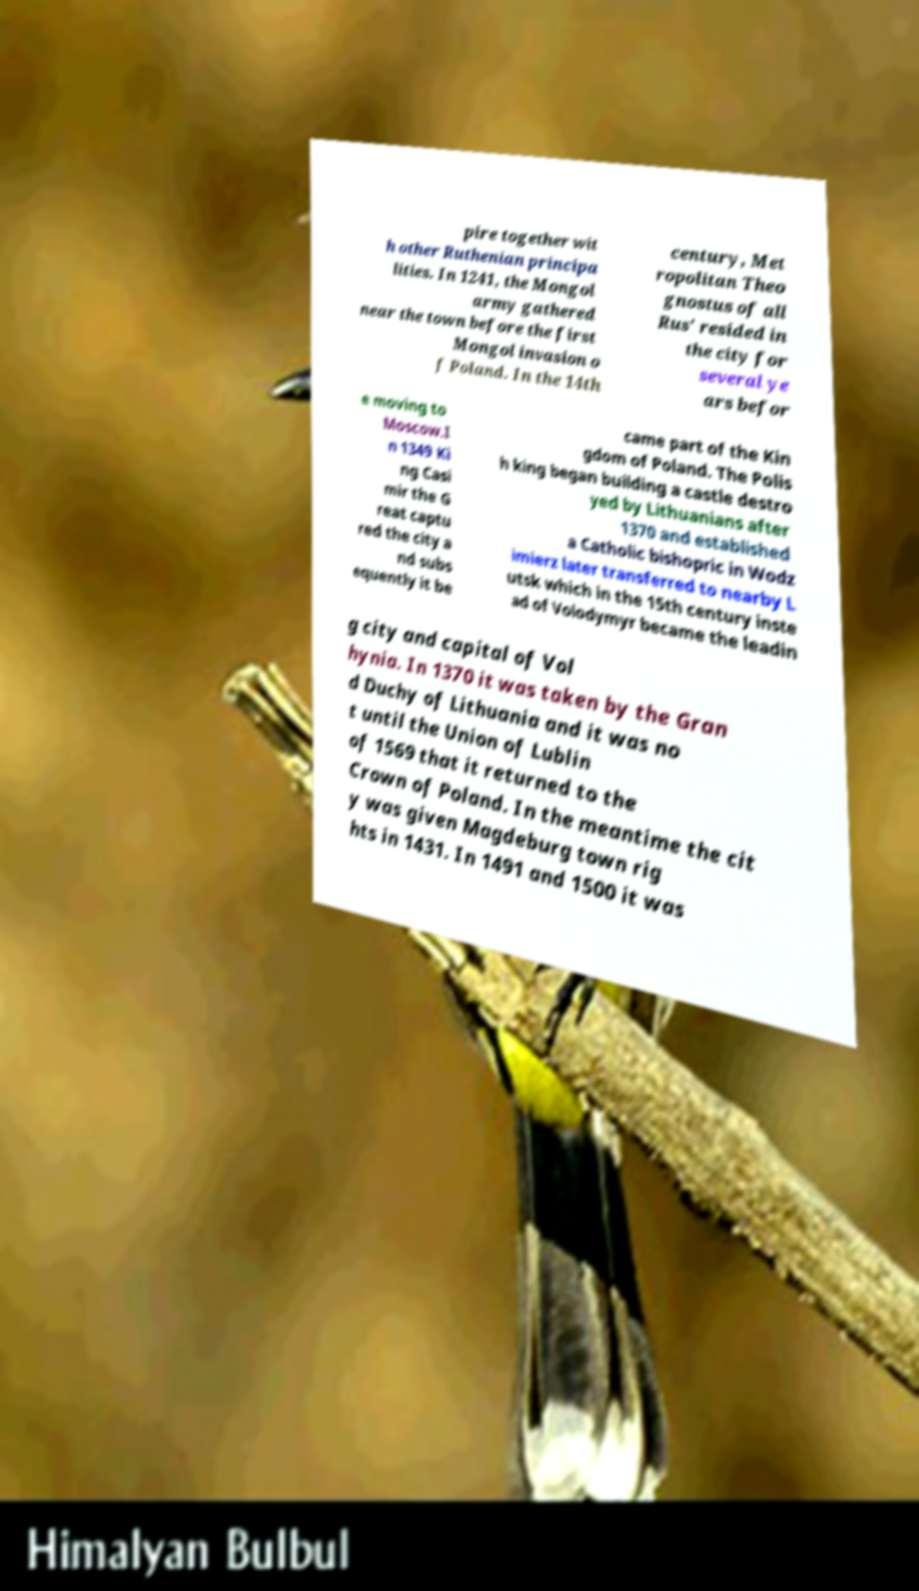I need the written content from this picture converted into text. Can you do that? pire together wit h other Ruthenian principa lities. In 1241, the Mongol army gathered near the town before the first Mongol invasion o f Poland. In the 14th century, Met ropolitan Theo gnostus of all Rus' resided in the city for several ye ars befor e moving to Moscow.I n 1349 Ki ng Casi mir the G reat captu red the city a nd subs equently it be came part of the Kin gdom of Poland. The Polis h king began building a castle destro yed by Lithuanians after 1370 and established a Catholic bishopric in Wodz imierz later transferred to nearby L utsk which in the 15th century inste ad of Volodymyr became the leadin g city and capital of Vol hynia. In 1370 it was taken by the Gran d Duchy of Lithuania and it was no t until the Union of Lublin of 1569 that it returned to the Crown of Poland. In the meantime the cit y was given Magdeburg town rig hts in 1431. In 1491 and 1500 it was 